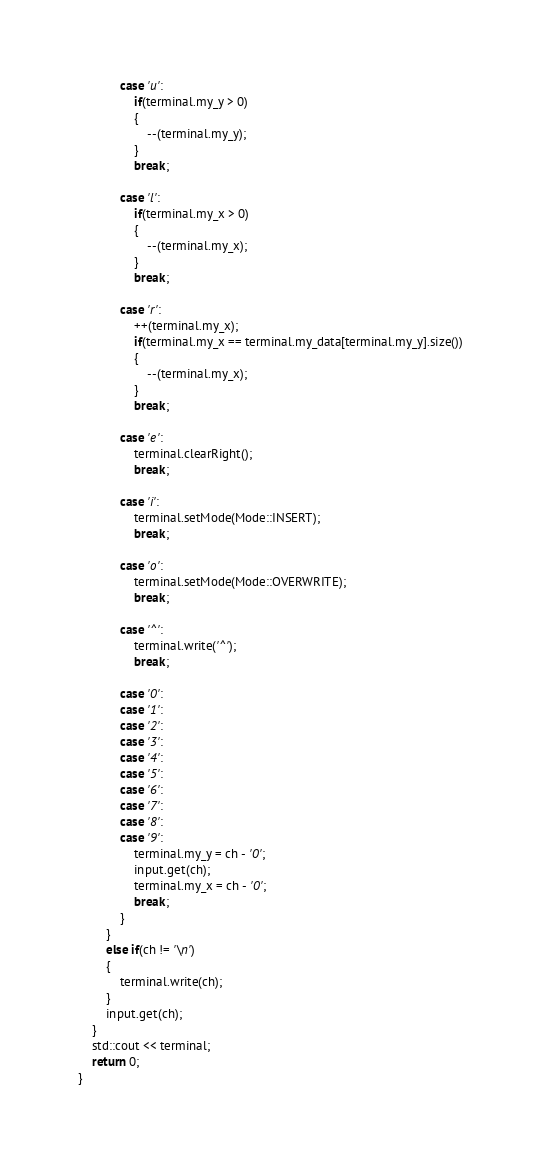Convert code to text. <code><loc_0><loc_0><loc_500><loc_500><_C++_>            case 'u':
                if(terminal.my_y > 0)
                {
                    --(terminal.my_y);
                }
                break;

            case 'l':
                if(terminal.my_x > 0)
                {
                    --(terminal.my_x);
                }
                break;

            case 'r':
                ++(terminal.my_x);
                if(terminal.my_x == terminal.my_data[terminal.my_y].size())
                {
                    --(terminal.my_x);
                }
                break;

            case 'e':
                terminal.clearRight();
                break;

            case 'i':
                terminal.setMode(Mode::INSERT);
                break;

            case 'o':
                terminal.setMode(Mode::OVERWRITE);
                break;

            case '^':
                terminal.write('^');
                break;

            case '0':
            case '1':
            case '2':
            case '3':
            case '4':
            case '5':
            case '6':
            case '7':
            case '8':
            case '9':
                terminal.my_y = ch - '0';
                input.get(ch);
                terminal.my_x = ch - '0';
                break;
            }
        }
        else if(ch != '\n')
        {
            terminal.write(ch);
        }
        input.get(ch);
    }
    std::cout << terminal;
    return 0;
}
</code> 